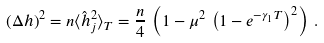Convert formula to latex. <formula><loc_0><loc_0><loc_500><loc_500>( \Delta h ) ^ { 2 } = n \langle \hat { h } _ { j } ^ { 2 } \rangle _ { T } = \frac { n } { 4 } \, \left ( 1 - \mu ^ { 2 } \, \left ( 1 - e ^ { - \gamma _ { 1 } T } \right ) ^ { 2 } \right ) \, .</formula> 